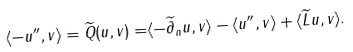<formula> <loc_0><loc_0><loc_500><loc_500>\langle - u ^ { \prime \prime } , v \rangle = \widetilde { Q } ( u , v ) = & \langle - \widetilde { \partial } _ { n } u , v \rangle - \langle u ^ { \prime \prime } , v \rangle + \langle \widetilde { L } u , v \rangle .</formula> 